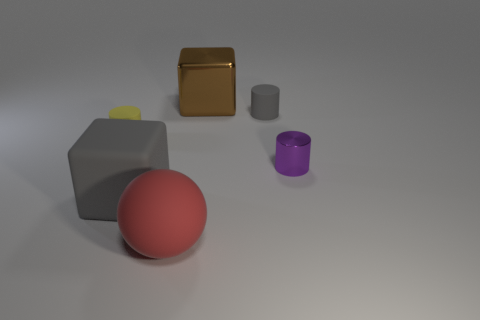Is the shape of the big brown shiny object the same as the gray rubber thing behind the small purple cylinder?
Provide a succinct answer. No. How big is the yellow matte object behind the small metallic cylinder?
Make the answer very short. Small. What is the yellow cylinder made of?
Provide a succinct answer. Rubber. There is a metallic object right of the gray cylinder; is its shape the same as the red thing?
Your response must be concise. No. There is a rubber object that is the same color as the big rubber block; what size is it?
Keep it short and to the point. Small. Are there any purple matte cubes of the same size as the red rubber sphere?
Ensure brevity in your answer.  No. There is a tiny matte cylinder that is on the left side of the tiny rubber cylinder that is to the right of the red sphere; are there any brown shiny blocks in front of it?
Offer a terse response. No. There is a large sphere; does it have the same color as the rubber cylinder that is on the left side of the gray cube?
Give a very brief answer. No. There is a cylinder in front of the thing to the left of the gray object in front of the shiny cylinder; what is its material?
Your response must be concise. Metal. What is the shape of the gray thing that is on the right side of the big gray object?
Ensure brevity in your answer.  Cylinder. 